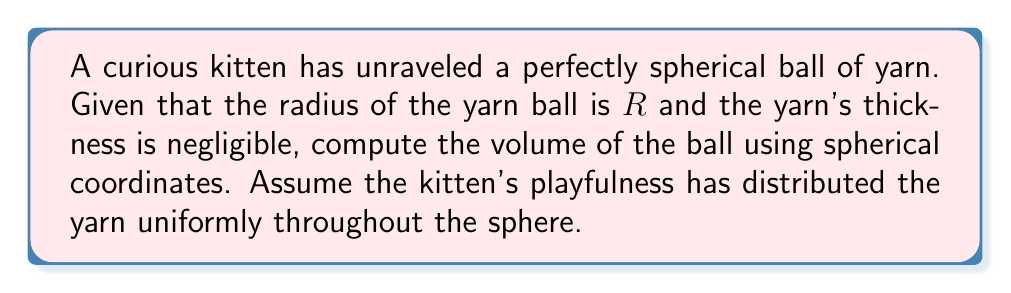Help me with this question. Let's approach this step-by-step:

1) In spherical coordinates, the volume element is given by:
   $$dV = r^2 \sin\theta \, dr \, d\theta \, d\phi$$

2) The limits of integration for a sphere are:
   $0 \leq r \leq R$ (radius)
   $0 \leq \theta \leq \pi$ (polar angle)
   $0 \leq \phi \leq 2\pi$ (azimuthal angle)

3) The volume is then given by the triple integral:
   $$V = \int_0^R \int_0^\pi \int_0^{2\pi} r^2 \sin\theta \, d\phi \, d\theta \, dr$$

4) Let's integrate from inside out:
   $$V = \int_0^R \int_0^\pi \left[ \int_0^{2\pi} d\phi \right] r^2 \sin\theta \, d\theta \, dr$$
   
   $$V = 2\pi \int_0^R \int_0^\pi r^2 \sin\theta \, d\theta \, dr$$

5) Now, integrate with respect to $\theta$:
   $$V = 2\pi \int_0^R r^2 \left[ -\cos\theta \right]_0^\pi \, dr$$
   
   $$V = 2\pi \int_0^R r^2 \cdot 2 \, dr$$

6) Finally, integrate with respect to $r$:
   $$V = 4\pi \left[ \frac{r^3}{3} \right]_0^R$$
   
   $$V = 4\pi \left( \frac{R^3}{3} - 0 \right)$$

7) This simplifies to:
   $$V = \frac{4}{3}\pi R^3$$

This is the well-known formula for the volume of a sphere with radius $R$.
Answer: $\frac{4}{3}\pi R^3$ 